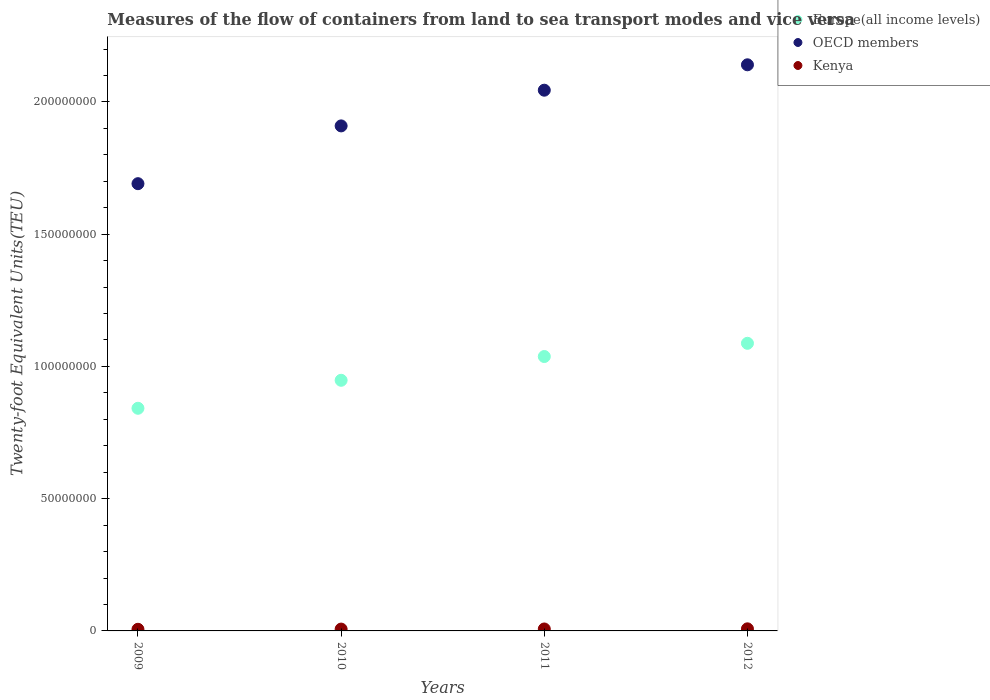How many different coloured dotlines are there?
Your response must be concise. 3. Is the number of dotlines equal to the number of legend labels?
Ensure brevity in your answer.  Yes. What is the container port traffic in Europe(all income levels) in 2011?
Your answer should be very brief. 1.04e+08. Across all years, what is the maximum container port traffic in Europe(all income levels)?
Provide a short and direct response. 1.09e+08. Across all years, what is the minimum container port traffic in OECD members?
Offer a very short reply. 1.69e+08. In which year was the container port traffic in Kenya minimum?
Make the answer very short. 2009. What is the total container port traffic in Kenya in the graph?
Offer a terse response. 2.84e+06. What is the difference between the container port traffic in Kenya in 2010 and that in 2012?
Ensure brevity in your answer.  -9.48e+04. What is the difference between the container port traffic in Europe(all income levels) in 2011 and the container port traffic in Kenya in 2009?
Offer a very short reply. 1.03e+08. What is the average container port traffic in Europe(all income levels) per year?
Provide a succinct answer. 9.79e+07. In the year 2011, what is the difference between the container port traffic in Kenya and container port traffic in Europe(all income levels)?
Your answer should be compact. -1.03e+08. In how many years, is the container port traffic in Kenya greater than 170000000 TEU?
Your answer should be very brief. 0. What is the ratio of the container port traffic in Europe(all income levels) in 2011 to that in 2012?
Offer a terse response. 0.95. Is the container port traffic in Kenya in 2011 less than that in 2012?
Offer a very short reply. Yes. What is the difference between the highest and the second highest container port traffic in Kenya?
Your response must be concise. 5.52e+04. What is the difference between the highest and the lowest container port traffic in OECD members?
Make the answer very short. 4.49e+07. In how many years, is the container port traffic in Europe(all income levels) greater than the average container port traffic in Europe(all income levels) taken over all years?
Ensure brevity in your answer.  2. Is the sum of the container port traffic in Europe(all income levels) in 2010 and 2012 greater than the maximum container port traffic in OECD members across all years?
Ensure brevity in your answer.  No. Is it the case that in every year, the sum of the container port traffic in Europe(all income levels) and container port traffic in Kenya  is greater than the container port traffic in OECD members?
Offer a terse response. No. Is the container port traffic in Kenya strictly greater than the container port traffic in Europe(all income levels) over the years?
Provide a short and direct response. No. Is the container port traffic in Kenya strictly less than the container port traffic in OECD members over the years?
Ensure brevity in your answer.  Yes. How many years are there in the graph?
Your answer should be compact. 4. Does the graph contain grids?
Offer a very short reply. No. Where does the legend appear in the graph?
Offer a terse response. Top right. What is the title of the graph?
Give a very brief answer. Measures of the flow of containers from land to sea transport modes and vice versa. Does "Europe(all income levels)" appear as one of the legend labels in the graph?
Give a very brief answer. Yes. What is the label or title of the Y-axis?
Make the answer very short. Twenty-foot Equivalent Units(TEU). What is the Twenty-foot Equivalent Units(TEU) of Europe(all income levels) in 2009?
Make the answer very short. 8.42e+07. What is the Twenty-foot Equivalent Units(TEU) in OECD members in 2009?
Provide a succinct answer. 1.69e+08. What is the Twenty-foot Equivalent Units(TEU) in Kenya in 2009?
Provide a succinct answer. 6.19e+05. What is the Twenty-foot Equivalent Units(TEU) of Europe(all income levels) in 2010?
Give a very brief answer. 9.48e+07. What is the Twenty-foot Equivalent Units(TEU) of OECD members in 2010?
Your response must be concise. 1.91e+08. What is the Twenty-foot Equivalent Units(TEU) in Kenya in 2010?
Your answer should be compact. 6.96e+05. What is the Twenty-foot Equivalent Units(TEU) in Europe(all income levels) in 2011?
Provide a succinct answer. 1.04e+08. What is the Twenty-foot Equivalent Units(TEU) of OECD members in 2011?
Your answer should be very brief. 2.04e+08. What is the Twenty-foot Equivalent Units(TEU) of Kenya in 2011?
Your response must be concise. 7.36e+05. What is the Twenty-foot Equivalent Units(TEU) in Europe(all income levels) in 2012?
Provide a short and direct response. 1.09e+08. What is the Twenty-foot Equivalent Units(TEU) of OECD members in 2012?
Make the answer very short. 2.14e+08. What is the Twenty-foot Equivalent Units(TEU) in Kenya in 2012?
Your response must be concise. 7.91e+05. Across all years, what is the maximum Twenty-foot Equivalent Units(TEU) of Europe(all income levels)?
Ensure brevity in your answer.  1.09e+08. Across all years, what is the maximum Twenty-foot Equivalent Units(TEU) of OECD members?
Your answer should be very brief. 2.14e+08. Across all years, what is the maximum Twenty-foot Equivalent Units(TEU) in Kenya?
Give a very brief answer. 7.91e+05. Across all years, what is the minimum Twenty-foot Equivalent Units(TEU) in Europe(all income levels)?
Make the answer very short. 8.42e+07. Across all years, what is the minimum Twenty-foot Equivalent Units(TEU) in OECD members?
Make the answer very short. 1.69e+08. Across all years, what is the minimum Twenty-foot Equivalent Units(TEU) of Kenya?
Your answer should be very brief. 6.19e+05. What is the total Twenty-foot Equivalent Units(TEU) in Europe(all income levels) in the graph?
Offer a terse response. 3.91e+08. What is the total Twenty-foot Equivalent Units(TEU) in OECD members in the graph?
Give a very brief answer. 7.79e+08. What is the total Twenty-foot Equivalent Units(TEU) of Kenya in the graph?
Your response must be concise. 2.84e+06. What is the difference between the Twenty-foot Equivalent Units(TEU) in Europe(all income levels) in 2009 and that in 2010?
Provide a succinct answer. -1.06e+07. What is the difference between the Twenty-foot Equivalent Units(TEU) in OECD members in 2009 and that in 2010?
Your answer should be very brief. -2.18e+07. What is the difference between the Twenty-foot Equivalent Units(TEU) in Kenya in 2009 and that in 2010?
Offer a very short reply. -7.72e+04. What is the difference between the Twenty-foot Equivalent Units(TEU) in Europe(all income levels) in 2009 and that in 2011?
Offer a very short reply. -1.96e+07. What is the difference between the Twenty-foot Equivalent Units(TEU) of OECD members in 2009 and that in 2011?
Your response must be concise. -3.53e+07. What is the difference between the Twenty-foot Equivalent Units(TEU) in Kenya in 2009 and that in 2011?
Make the answer very short. -1.17e+05. What is the difference between the Twenty-foot Equivalent Units(TEU) in Europe(all income levels) in 2009 and that in 2012?
Offer a terse response. -2.46e+07. What is the difference between the Twenty-foot Equivalent Units(TEU) of OECD members in 2009 and that in 2012?
Give a very brief answer. -4.49e+07. What is the difference between the Twenty-foot Equivalent Units(TEU) of Kenya in 2009 and that in 2012?
Offer a terse response. -1.72e+05. What is the difference between the Twenty-foot Equivalent Units(TEU) in Europe(all income levels) in 2010 and that in 2011?
Make the answer very short. -8.99e+06. What is the difference between the Twenty-foot Equivalent Units(TEU) in OECD members in 2010 and that in 2011?
Your response must be concise. -1.35e+07. What is the difference between the Twenty-foot Equivalent Units(TEU) in Kenya in 2010 and that in 2011?
Provide a short and direct response. -3.97e+04. What is the difference between the Twenty-foot Equivalent Units(TEU) of Europe(all income levels) in 2010 and that in 2012?
Offer a terse response. -1.40e+07. What is the difference between the Twenty-foot Equivalent Units(TEU) of OECD members in 2010 and that in 2012?
Offer a terse response. -2.31e+07. What is the difference between the Twenty-foot Equivalent Units(TEU) in Kenya in 2010 and that in 2012?
Provide a short and direct response. -9.48e+04. What is the difference between the Twenty-foot Equivalent Units(TEU) in Europe(all income levels) in 2011 and that in 2012?
Give a very brief answer. -5.00e+06. What is the difference between the Twenty-foot Equivalent Units(TEU) of OECD members in 2011 and that in 2012?
Provide a short and direct response. -9.60e+06. What is the difference between the Twenty-foot Equivalent Units(TEU) in Kenya in 2011 and that in 2012?
Give a very brief answer. -5.52e+04. What is the difference between the Twenty-foot Equivalent Units(TEU) in Europe(all income levels) in 2009 and the Twenty-foot Equivalent Units(TEU) in OECD members in 2010?
Offer a very short reply. -1.07e+08. What is the difference between the Twenty-foot Equivalent Units(TEU) of Europe(all income levels) in 2009 and the Twenty-foot Equivalent Units(TEU) of Kenya in 2010?
Your answer should be very brief. 8.35e+07. What is the difference between the Twenty-foot Equivalent Units(TEU) of OECD members in 2009 and the Twenty-foot Equivalent Units(TEU) of Kenya in 2010?
Provide a short and direct response. 1.68e+08. What is the difference between the Twenty-foot Equivalent Units(TEU) in Europe(all income levels) in 2009 and the Twenty-foot Equivalent Units(TEU) in OECD members in 2011?
Make the answer very short. -1.20e+08. What is the difference between the Twenty-foot Equivalent Units(TEU) in Europe(all income levels) in 2009 and the Twenty-foot Equivalent Units(TEU) in Kenya in 2011?
Make the answer very short. 8.34e+07. What is the difference between the Twenty-foot Equivalent Units(TEU) in OECD members in 2009 and the Twenty-foot Equivalent Units(TEU) in Kenya in 2011?
Give a very brief answer. 1.68e+08. What is the difference between the Twenty-foot Equivalent Units(TEU) of Europe(all income levels) in 2009 and the Twenty-foot Equivalent Units(TEU) of OECD members in 2012?
Provide a short and direct response. -1.30e+08. What is the difference between the Twenty-foot Equivalent Units(TEU) in Europe(all income levels) in 2009 and the Twenty-foot Equivalent Units(TEU) in Kenya in 2012?
Ensure brevity in your answer.  8.34e+07. What is the difference between the Twenty-foot Equivalent Units(TEU) in OECD members in 2009 and the Twenty-foot Equivalent Units(TEU) in Kenya in 2012?
Your answer should be very brief. 1.68e+08. What is the difference between the Twenty-foot Equivalent Units(TEU) in Europe(all income levels) in 2010 and the Twenty-foot Equivalent Units(TEU) in OECD members in 2011?
Provide a short and direct response. -1.10e+08. What is the difference between the Twenty-foot Equivalent Units(TEU) in Europe(all income levels) in 2010 and the Twenty-foot Equivalent Units(TEU) in Kenya in 2011?
Keep it short and to the point. 9.40e+07. What is the difference between the Twenty-foot Equivalent Units(TEU) in OECD members in 2010 and the Twenty-foot Equivalent Units(TEU) in Kenya in 2011?
Your response must be concise. 1.90e+08. What is the difference between the Twenty-foot Equivalent Units(TEU) of Europe(all income levels) in 2010 and the Twenty-foot Equivalent Units(TEU) of OECD members in 2012?
Provide a short and direct response. -1.19e+08. What is the difference between the Twenty-foot Equivalent Units(TEU) in Europe(all income levels) in 2010 and the Twenty-foot Equivalent Units(TEU) in Kenya in 2012?
Offer a terse response. 9.40e+07. What is the difference between the Twenty-foot Equivalent Units(TEU) in OECD members in 2010 and the Twenty-foot Equivalent Units(TEU) in Kenya in 2012?
Your answer should be very brief. 1.90e+08. What is the difference between the Twenty-foot Equivalent Units(TEU) of Europe(all income levels) in 2011 and the Twenty-foot Equivalent Units(TEU) of OECD members in 2012?
Make the answer very short. -1.10e+08. What is the difference between the Twenty-foot Equivalent Units(TEU) in Europe(all income levels) in 2011 and the Twenty-foot Equivalent Units(TEU) in Kenya in 2012?
Keep it short and to the point. 1.03e+08. What is the difference between the Twenty-foot Equivalent Units(TEU) in OECD members in 2011 and the Twenty-foot Equivalent Units(TEU) in Kenya in 2012?
Keep it short and to the point. 2.04e+08. What is the average Twenty-foot Equivalent Units(TEU) of Europe(all income levels) per year?
Offer a terse response. 9.79e+07. What is the average Twenty-foot Equivalent Units(TEU) of OECD members per year?
Keep it short and to the point. 1.95e+08. What is the average Twenty-foot Equivalent Units(TEU) of Kenya per year?
Give a very brief answer. 7.10e+05. In the year 2009, what is the difference between the Twenty-foot Equivalent Units(TEU) in Europe(all income levels) and Twenty-foot Equivalent Units(TEU) in OECD members?
Provide a succinct answer. -8.49e+07. In the year 2009, what is the difference between the Twenty-foot Equivalent Units(TEU) of Europe(all income levels) and Twenty-foot Equivalent Units(TEU) of Kenya?
Offer a terse response. 8.36e+07. In the year 2009, what is the difference between the Twenty-foot Equivalent Units(TEU) of OECD members and Twenty-foot Equivalent Units(TEU) of Kenya?
Keep it short and to the point. 1.68e+08. In the year 2010, what is the difference between the Twenty-foot Equivalent Units(TEU) in Europe(all income levels) and Twenty-foot Equivalent Units(TEU) in OECD members?
Offer a very short reply. -9.62e+07. In the year 2010, what is the difference between the Twenty-foot Equivalent Units(TEU) in Europe(all income levels) and Twenty-foot Equivalent Units(TEU) in Kenya?
Give a very brief answer. 9.41e+07. In the year 2010, what is the difference between the Twenty-foot Equivalent Units(TEU) in OECD members and Twenty-foot Equivalent Units(TEU) in Kenya?
Your answer should be very brief. 1.90e+08. In the year 2011, what is the difference between the Twenty-foot Equivalent Units(TEU) in Europe(all income levels) and Twenty-foot Equivalent Units(TEU) in OECD members?
Give a very brief answer. -1.01e+08. In the year 2011, what is the difference between the Twenty-foot Equivalent Units(TEU) of Europe(all income levels) and Twenty-foot Equivalent Units(TEU) of Kenya?
Offer a very short reply. 1.03e+08. In the year 2011, what is the difference between the Twenty-foot Equivalent Units(TEU) in OECD members and Twenty-foot Equivalent Units(TEU) in Kenya?
Your answer should be compact. 2.04e+08. In the year 2012, what is the difference between the Twenty-foot Equivalent Units(TEU) in Europe(all income levels) and Twenty-foot Equivalent Units(TEU) in OECD members?
Provide a short and direct response. -1.05e+08. In the year 2012, what is the difference between the Twenty-foot Equivalent Units(TEU) in Europe(all income levels) and Twenty-foot Equivalent Units(TEU) in Kenya?
Offer a terse response. 1.08e+08. In the year 2012, what is the difference between the Twenty-foot Equivalent Units(TEU) of OECD members and Twenty-foot Equivalent Units(TEU) of Kenya?
Offer a very short reply. 2.13e+08. What is the ratio of the Twenty-foot Equivalent Units(TEU) in Europe(all income levels) in 2009 to that in 2010?
Offer a very short reply. 0.89. What is the ratio of the Twenty-foot Equivalent Units(TEU) in OECD members in 2009 to that in 2010?
Offer a very short reply. 0.89. What is the ratio of the Twenty-foot Equivalent Units(TEU) of Kenya in 2009 to that in 2010?
Provide a succinct answer. 0.89. What is the ratio of the Twenty-foot Equivalent Units(TEU) in Europe(all income levels) in 2009 to that in 2011?
Offer a very short reply. 0.81. What is the ratio of the Twenty-foot Equivalent Units(TEU) of OECD members in 2009 to that in 2011?
Ensure brevity in your answer.  0.83. What is the ratio of the Twenty-foot Equivalent Units(TEU) in Kenya in 2009 to that in 2011?
Ensure brevity in your answer.  0.84. What is the ratio of the Twenty-foot Equivalent Units(TEU) of Europe(all income levels) in 2009 to that in 2012?
Your answer should be compact. 0.77. What is the ratio of the Twenty-foot Equivalent Units(TEU) in OECD members in 2009 to that in 2012?
Ensure brevity in your answer.  0.79. What is the ratio of the Twenty-foot Equivalent Units(TEU) in Kenya in 2009 to that in 2012?
Ensure brevity in your answer.  0.78. What is the ratio of the Twenty-foot Equivalent Units(TEU) in Europe(all income levels) in 2010 to that in 2011?
Offer a very short reply. 0.91. What is the ratio of the Twenty-foot Equivalent Units(TEU) of OECD members in 2010 to that in 2011?
Your response must be concise. 0.93. What is the ratio of the Twenty-foot Equivalent Units(TEU) in Kenya in 2010 to that in 2011?
Provide a succinct answer. 0.95. What is the ratio of the Twenty-foot Equivalent Units(TEU) of Europe(all income levels) in 2010 to that in 2012?
Make the answer very short. 0.87. What is the ratio of the Twenty-foot Equivalent Units(TEU) in OECD members in 2010 to that in 2012?
Provide a succinct answer. 0.89. What is the ratio of the Twenty-foot Equivalent Units(TEU) in Kenya in 2010 to that in 2012?
Offer a terse response. 0.88. What is the ratio of the Twenty-foot Equivalent Units(TEU) in Europe(all income levels) in 2011 to that in 2012?
Give a very brief answer. 0.95. What is the ratio of the Twenty-foot Equivalent Units(TEU) in OECD members in 2011 to that in 2012?
Keep it short and to the point. 0.96. What is the ratio of the Twenty-foot Equivalent Units(TEU) in Kenya in 2011 to that in 2012?
Offer a terse response. 0.93. What is the difference between the highest and the second highest Twenty-foot Equivalent Units(TEU) in Europe(all income levels)?
Offer a very short reply. 5.00e+06. What is the difference between the highest and the second highest Twenty-foot Equivalent Units(TEU) of OECD members?
Your answer should be very brief. 9.60e+06. What is the difference between the highest and the second highest Twenty-foot Equivalent Units(TEU) in Kenya?
Offer a terse response. 5.52e+04. What is the difference between the highest and the lowest Twenty-foot Equivalent Units(TEU) of Europe(all income levels)?
Keep it short and to the point. 2.46e+07. What is the difference between the highest and the lowest Twenty-foot Equivalent Units(TEU) of OECD members?
Your answer should be very brief. 4.49e+07. What is the difference between the highest and the lowest Twenty-foot Equivalent Units(TEU) in Kenya?
Make the answer very short. 1.72e+05. 